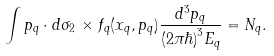<formula> <loc_0><loc_0><loc_500><loc_500>\int p _ { q } \cdot d \sigma _ { 2 } \, \times f _ { q } ( x _ { q } , p _ { q } ) \frac { d ^ { 3 } p _ { q } } { ( 2 \pi \hbar { ) } ^ { 3 } E _ { q } } = N _ { q } .</formula> 